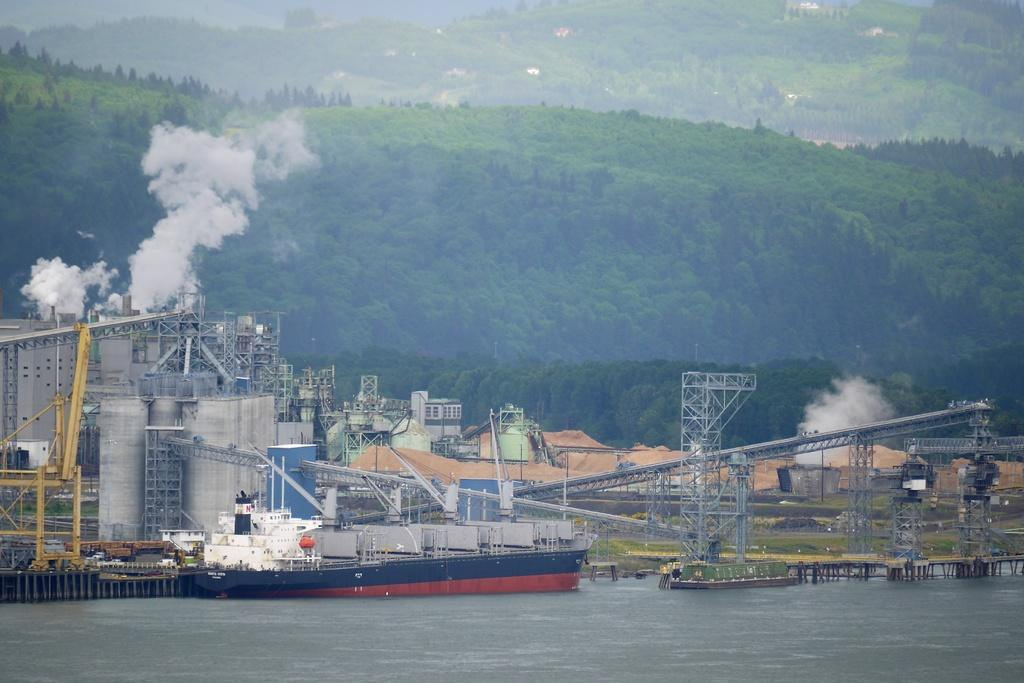What type of structure is present in the image? There is a factory in the image. What is happening with the factory in the image? Smoke is releasing from the factory. What can be found inside the factory? There are machines in the image. What is located near the factory? There is a ship in the water. What type of natural landscape is visible in the image? Trees are visible on the hills. Who is the writer of the story depicted in the image? There is no story depicted in the image; it shows a factory, smoke, machines, a ship, and trees on hills. 